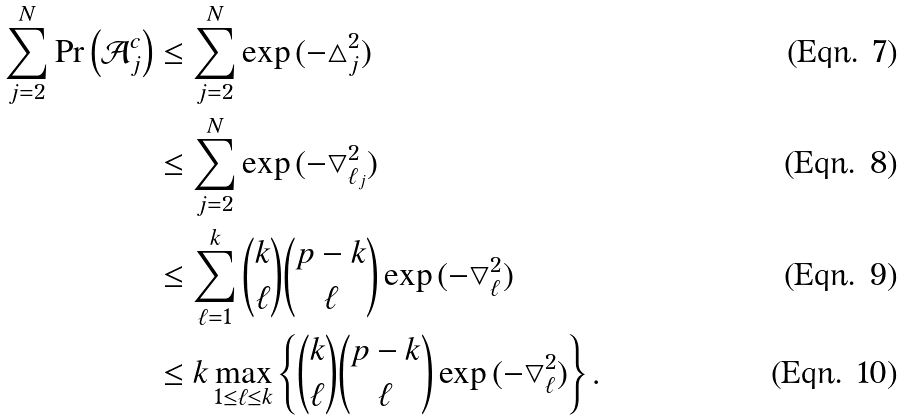Convert formula to latex. <formula><loc_0><loc_0><loc_500><loc_500>\sum _ { j = 2 } ^ { N } \Pr \left ( \mathcal { A } _ { j } ^ { c } \right ) & \leq \sum _ { j = 2 } ^ { N } \exp { ( - \bigtriangleup _ { j } ^ { 2 } ) } \\ & \leq \sum _ { j = 2 } ^ { N } \exp { ( - \bigtriangledown _ { \ell _ { j } } ^ { 2 } ) } \\ & \leq \sum _ { \ell = 1 } ^ { k } { k \choose \ell } { p - k \choose \ell } \exp { ( - \bigtriangledown _ { \ell } ^ { 2 } ) } \\ & \leq k \max _ { 1 \leq \ell \leq k } \left \{ { k \choose \ell } { p - k \choose \ell } \exp { ( - \bigtriangledown _ { \ell } ^ { 2 } ) } \right \} .</formula> 